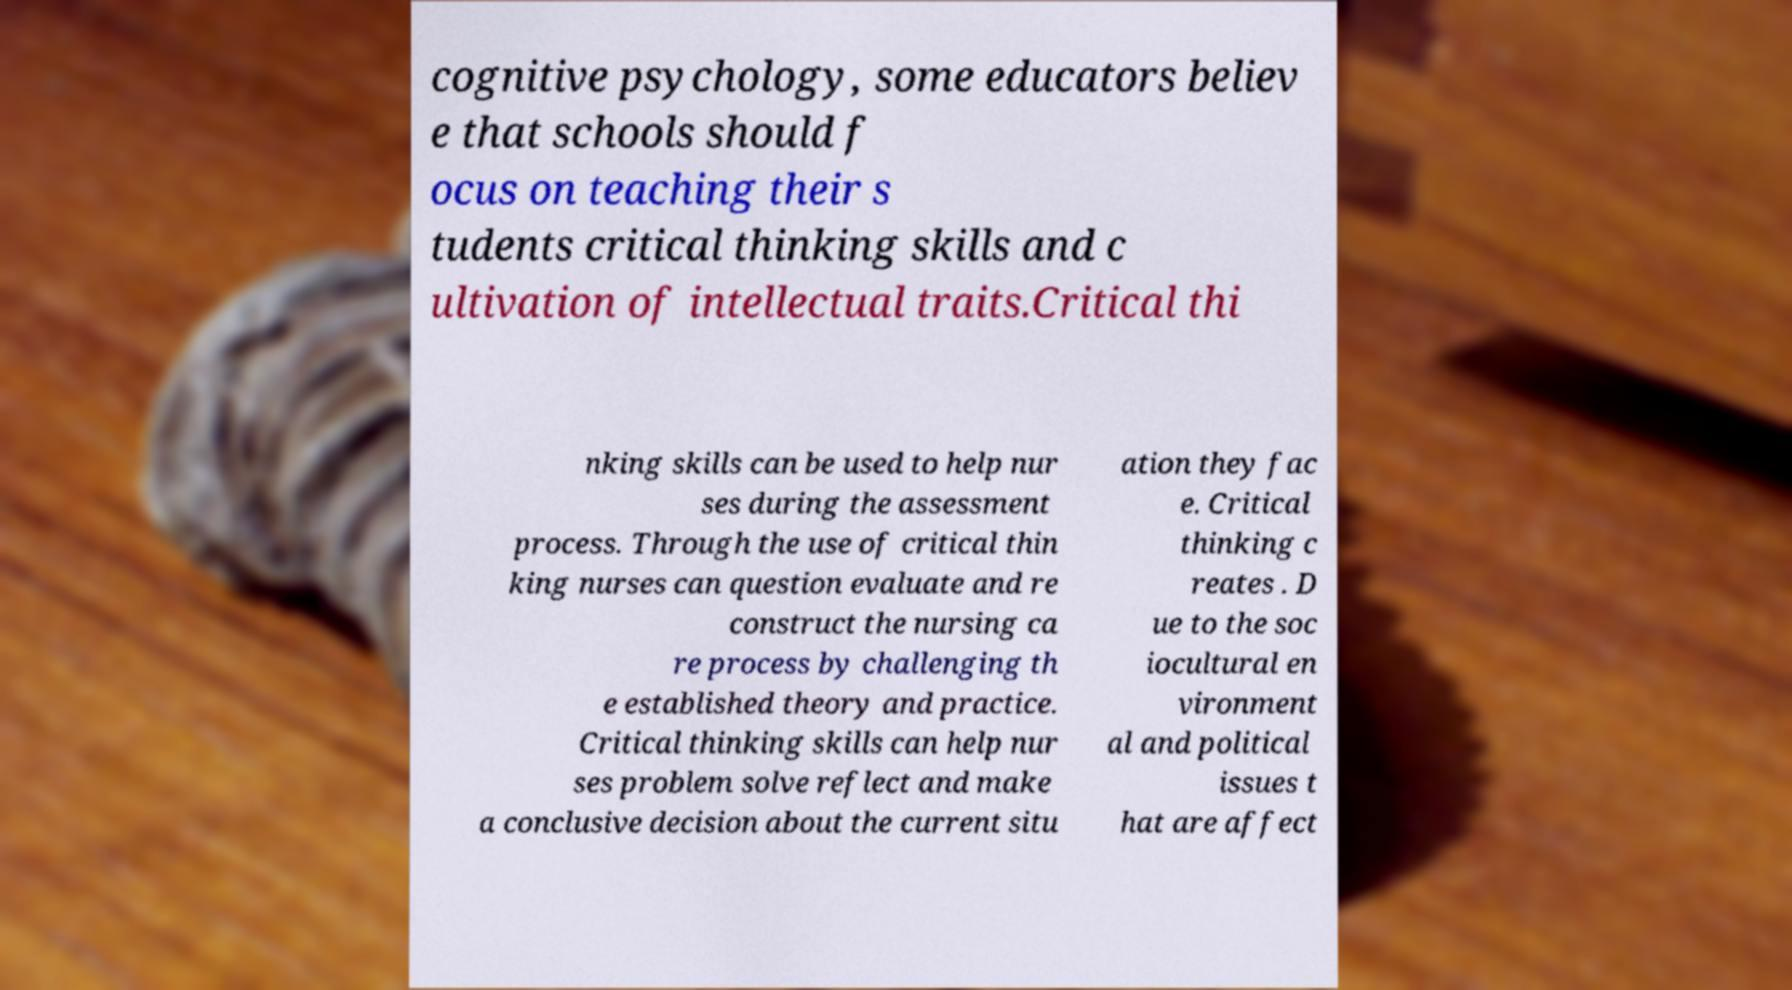What messages or text are displayed in this image? I need them in a readable, typed format. cognitive psychology, some educators believ e that schools should f ocus on teaching their s tudents critical thinking skills and c ultivation of intellectual traits.Critical thi nking skills can be used to help nur ses during the assessment process. Through the use of critical thin king nurses can question evaluate and re construct the nursing ca re process by challenging th e established theory and practice. Critical thinking skills can help nur ses problem solve reflect and make a conclusive decision about the current situ ation they fac e. Critical thinking c reates . D ue to the soc iocultural en vironment al and political issues t hat are affect 